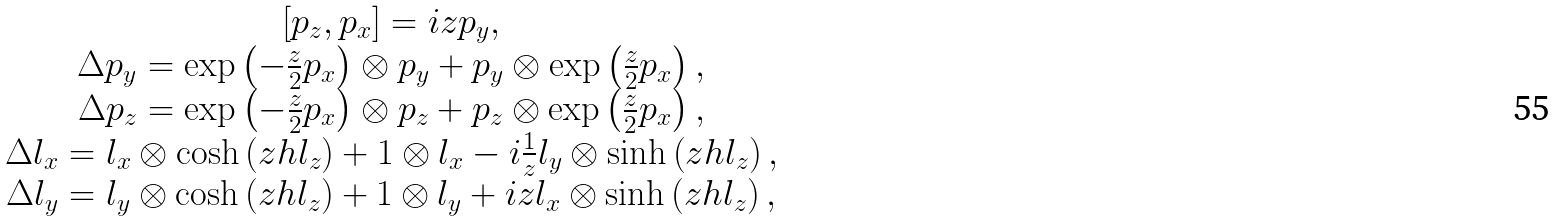Convert formula to latex. <formula><loc_0><loc_0><loc_500><loc_500>\begin{array} { c } [ p _ { z } , p _ { x } ] = i z p _ { y } , \\ \Delta p _ { y } = \exp \left ( - \frac { z } { 2 } p _ { x } \right ) \otimes p _ { y } + p _ { y } \otimes \exp \left ( \frac { z } { 2 } p _ { x } \right ) , \\ \Delta p _ { z } = \exp \left ( - \frac { z } { 2 } p _ { x } \right ) \otimes p _ { z } + p _ { z } \otimes \exp \left ( \frac { z } { 2 } p _ { x } \right ) , \\ \Delta l _ { x } = l _ { x } \otimes \cosh \left ( z h l _ { z } \right ) + 1 \otimes l _ { x } - i \frac { 1 } { z } l _ { y } \otimes \sinh \left ( z h l _ { z } \right ) , \\ \Delta l _ { y } = l _ { y } \otimes \cosh \left ( z h l _ { z } \right ) + 1 \otimes l _ { y } + i z l _ { x } \otimes \sinh \left ( z h l _ { z } \right ) , \end{array}</formula> 